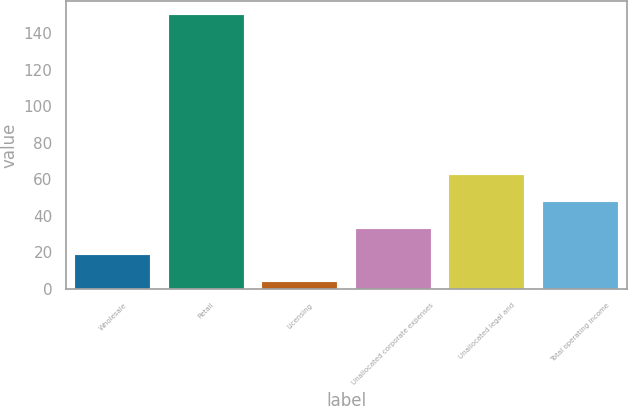Convert chart to OTSL. <chart><loc_0><loc_0><loc_500><loc_500><bar_chart><fcel>Wholesale<fcel>Retail<fcel>Licensing<fcel>Unallocated corporate expenses<fcel>Unallocated legal and<fcel>Total operating income<nl><fcel>18.34<fcel>150.1<fcel>3.7<fcel>32.98<fcel>62.26<fcel>47.62<nl></chart> 